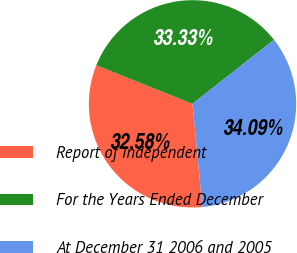<chart> <loc_0><loc_0><loc_500><loc_500><pie_chart><fcel>Report of Independent<fcel>For the Years Ended December<fcel>At December 31 2006 and 2005<nl><fcel>32.58%<fcel>33.33%<fcel>34.09%<nl></chart> 